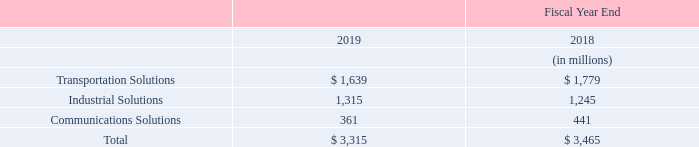Seasonality and Backlog
We experience a slight seasonal pattern to our business. Overall, the third and fourth fiscal quarters are typically the strongest quarters of our fiscal year, whereas the first fiscal quarter is negatively affected by holidays and the second fiscal quarter may be affected by adverse winter weather conditions in some of our markets.
Certain of our end markets experience some seasonality. Our sales in the automotive market are dependent upon global automotive production, and seasonal declines in European production may negatively impact net sales in the fourth fiscal quarter. Also, our sales in the energy market typically increase in the third and fourth fiscal quarters as customer activity increases.
Customer orders typically fluctuate from quarter to quarter based upon business and market conditions. Backlog is not necessarily indicative of future net sales as unfilled orders may be cancelled prior to shipment of goods. Backlog by reportable segment was as follows:
We expect that the majority of our backlog at fiscal year end 2019 will be filled during fiscal 2020.
What are sales in the automotive market dependent upon? Dependent upon global automotive production, and seasonal declines in european production may negatively impact net sales in the fourth fiscal quarter. When do sales in the energy market typically increase? In the third and fourth fiscal quarters as customer activity increases. What were the segments for which backlog was calculated in the table? Transportation solutions, industrial solutions, communications solutions. In which year was Communications Solutions larger? 441>361
Answer: 2018. What was the change in total backlog in 2019 from 2018?
Answer scale should be: million. 3,315-3,465
Answer: -150. What was the percentage change in total backlog in 2019 from 2018?
Answer scale should be: percent. (3,315-3,465)/3,465
Answer: -4.33. 